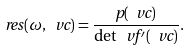Convert formula to latex. <formula><loc_0><loc_0><loc_500><loc_500>\ r e s ( \omega , \ v c ) = \frac { p ( \ v c ) } { \det \ v f ^ { \prime } ( \ v c ) } .</formula> 